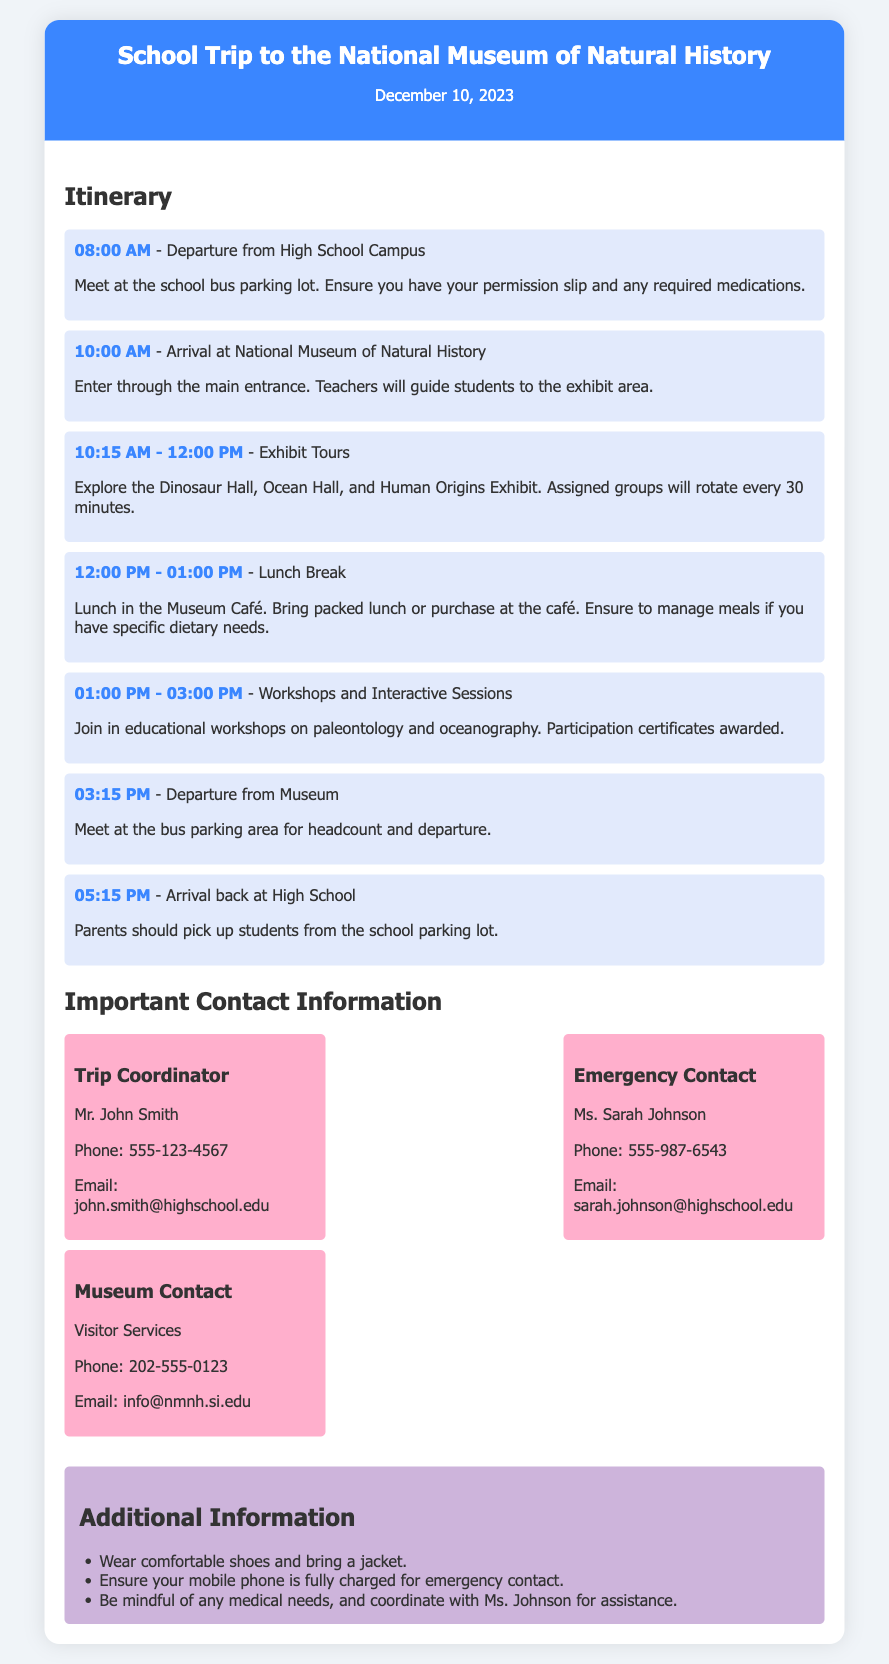What is the date of the school trip? The date of the school trip is mentioned in the header of the document.
Answer: December 10, 2023 Who is the Trip Coordinator? The Trip Coordinator's name is clearly listed in the Important Contact Information section.
Answer: Mr. John Smith At what time is the departure from the high school campus? The itinerary specifies the departure time from the high school.
Answer: 08:00 AM How long is the lunch break? The itinerary outlines the duration of the lunch break in the schedule.
Answer: 01:00 PM What activities will students participate in from 01:00 PM to 03:00 PM? The itinerary details the planned activities during that specific time frame.
Answer: Workshops and Interactive Sessions What should students bring in case of specific dietary needs? The itinerary includes instructions related to dietary concerns during the lunch period.
Answer: Packed lunch Who to contact for emergencies? The document provides information on the designated emergency contact.
Answer: Ms. Sarah Johnson What is the phone number for Visitor Services at the museum? The contact details for the museum are listed under Important Contact Information.
Answer: 202-555-0123 What should students wear for the trip? The additional information section provides advice on the appropriate attire for the trip.
Answer: Comfortable shoes 